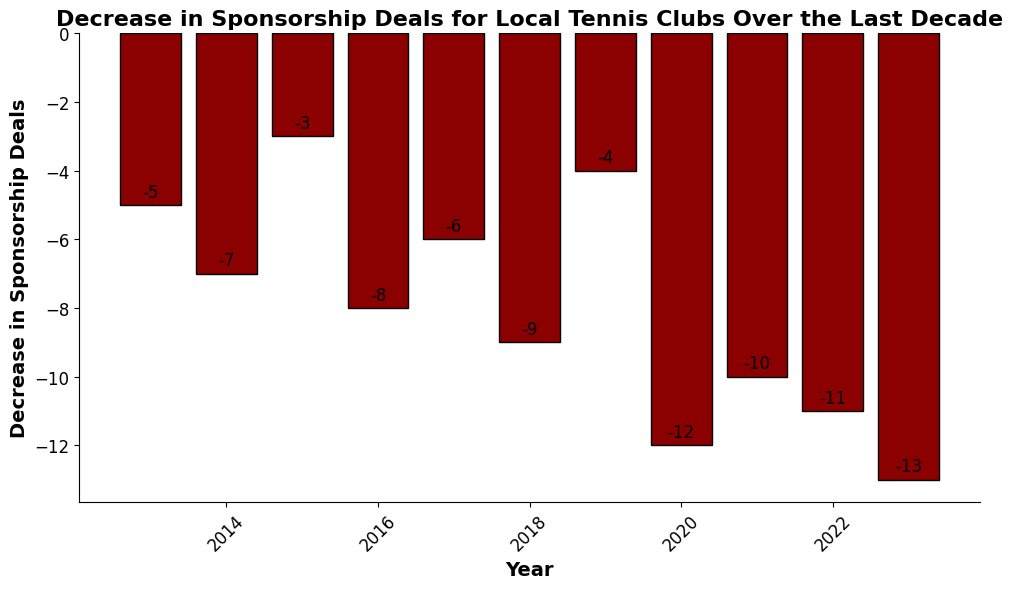What year experienced the greatest decrease in sponsorship deals? From the bar chart, look at the heights of the bars. The tallest bar corresponds to 2023 with a decrease of -13 sponsorship deals.
Answer: 2023 How many years had a decrease greater than 10 sponsorship deals? Identify the bars with heights less than -10. These correspond to the years 2020, 2021, 2022, and 2023.
Answer: 4 What is the average decrease in sponsorship deals over the decade? Sum the decreases for all years: (-5) + (-7) + (-3) + (-8) + (-6) + (-9) + (-4) + (-12) + (-10) + (-11) + (-13) = -88. Divide by the number of years (11). (-88) / 11 = -8.
Answer: -8 Which year had a smaller decrease in sponsorship deals: 2015 or 2019? Compare the decrease values for 2015 (-3) and 2019 (-4). -3 is smaller than -4.
Answer: 2015 By how much did the decrease in sponsorship deals change from 2018 to 2020? Calculate the difference in decrease values between 2020 (-12) and 2018 (-9). -12 - (-9) = -3.
Answer: -3 In which year(s) did the decrease in sponsorship deals fall below -10? Identify the years where the decrease is less than -10. These years are 2020 (-12), 2021 (-10), 2022 (-11), and 2023 (-13).
Answer: 2020, 2021, 2022, 2023 Is the decrease in sponsorship deals for 2017 less than that for 2016? Compare the decrease values for 2017 (-6) and 2016 (-8). -6 is greater than -8, so the decrease in 2017 is less.
Answer: Yes What is the difference between the smallest and largest decreases in sponsorship deals among the years? Identify the smallest and largest decrease values. The smallest is 2015 (-3) and the largest is 2023 (-13). The difference is (-13) - (-3) = -10.
Answer: -10 